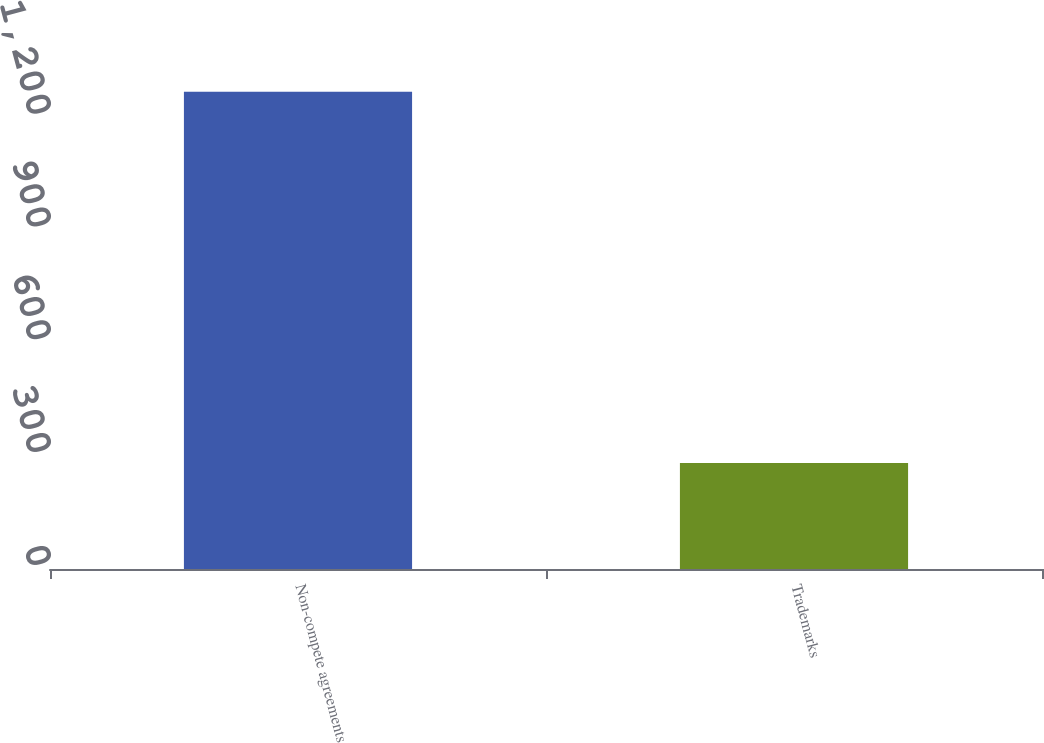<chart> <loc_0><loc_0><loc_500><loc_500><bar_chart><fcel>Non-compete agreements<fcel>Trademarks<nl><fcel>1269<fcel>282<nl></chart> 